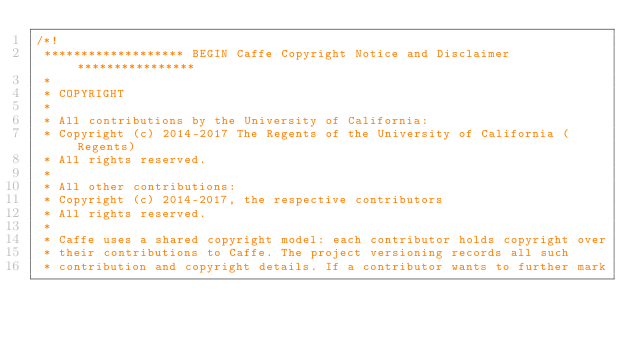<code> <loc_0><loc_0><loc_500><loc_500><_Cuda_>/*!
 ******************* BEGIN Caffe Copyright Notice and Disclaimer ****************
 *
 * COPYRIGHT
 *
 * All contributions by the University of California:
 * Copyright (c) 2014-2017 The Regents of the University of California (Regents)
 * All rights reserved.
 *
 * All other contributions:
 * Copyright (c) 2014-2017, the respective contributors
 * All rights reserved.
 *
 * Caffe uses a shared copyright model: each contributor holds copyright over
 * their contributions to Caffe. The project versioning records all such
 * contribution and copyright details. If a contributor wants to further mark</code> 